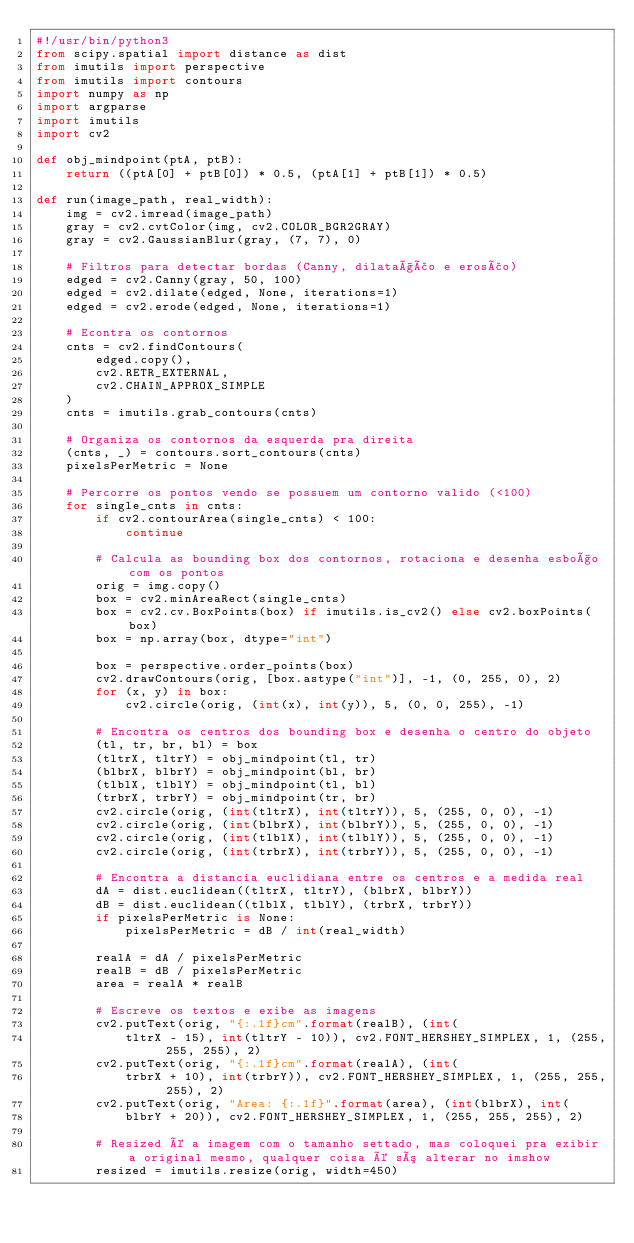<code> <loc_0><loc_0><loc_500><loc_500><_Python_>#!/usr/bin/python3
from scipy.spatial import distance as dist
from imutils import perspective
from imutils import contours
import numpy as np
import argparse
import imutils
import cv2

def obj_mindpoint(ptA, ptB):
    return ((ptA[0] + ptB[0]) * 0.5, (ptA[1] + ptB[1]) * 0.5)

def run(image_path, real_width):
    img = cv2.imread(image_path)
    gray = cv2.cvtColor(img, cv2.COLOR_BGR2GRAY)
    gray = cv2.GaussianBlur(gray, (7, 7), 0)

    # Filtros para detectar bordas (Canny, dilatação e erosão)
    edged = cv2.Canny(gray, 50, 100)
    edged = cv2.dilate(edged, None, iterations=1)
    edged = cv2.erode(edged, None, iterations=1)

    # Econtra os contornos
    cnts = cv2.findContours(
        edged.copy(), 
        cv2.RETR_EXTERNAL,
        cv2.CHAIN_APPROX_SIMPLE
    )
    cnts = imutils.grab_contours(cnts)

    # Organiza os contornos da esquerda pra direita
    (cnts, _) = contours.sort_contours(cnts)
    pixelsPerMetric = None

    # Percorre os pontos vendo se possuem um contorno valido (<100)
    for single_cnts in cnts:
        if cv2.contourArea(single_cnts) < 100:
            continue

        # Calcula as bounding box dos contornos, rotaciona e desenha esboço com os pontos
        orig = img.copy()
        box = cv2.minAreaRect(single_cnts)
        box = cv2.cv.BoxPoints(box) if imutils.is_cv2() else cv2.boxPoints(box)
        box = np.array(box, dtype="int")

        box = perspective.order_points(box)
        cv2.drawContours(orig, [box.astype("int")], -1, (0, 255, 0), 2)
        for (x, y) in box:
            cv2.circle(orig, (int(x), int(y)), 5, (0, 0, 255), -1)

        # Encontra os centros dos bounding box e desenha o centro do objeto
        (tl, tr, br, bl) = box
        (tltrX, tltrY) = obj_mindpoint(tl, tr)
        (blbrX, blbrY) = obj_mindpoint(bl, br)
        (tlblX, tlblY) = obj_mindpoint(tl, bl)
        (trbrX, trbrY) = obj_mindpoint(tr, br)
        cv2.circle(orig, (int(tltrX), int(tltrY)), 5, (255, 0, 0), -1)
        cv2.circle(orig, (int(blbrX), int(blbrY)), 5, (255, 0, 0), -1)
        cv2.circle(orig, (int(tlblX), int(tlblY)), 5, (255, 0, 0), -1)
        cv2.circle(orig, (int(trbrX), int(trbrY)), 5, (255, 0, 0), -1)

        # Encontra a distancia euclidiana entre os centros e a medida real
        dA = dist.euclidean((tltrX, tltrY), (blbrX, blbrY))
        dB = dist.euclidean((tlblX, tlblY), (trbrX, trbrY))
        if pixelsPerMetric is None:
            pixelsPerMetric = dB / int(real_width)

        realA = dA / pixelsPerMetric
        realB = dB / pixelsPerMetric
        area = realA * realB

        # Escreve os textos e exibe as imagens
        cv2.putText(orig, "{:.1f}cm".format(realB), (int(
            tltrX - 15), int(tltrY - 10)), cv2.FONT_HERSHEY_SIMPLEX, 1, (255, 255, 255), 2)
        cv2.putText(orig, "{:.1f}cm".format(realA), (int(
            trbrX + 10), int(trbrY)), cv2.FONT_HERSHEY_SIMPLEX, 1, (255, 255, 255), 2)
        cv2.putText(orig, "Area: {:.1f}".format(area), (int(blbrX), int(
            blbrY + 20)), cv2.FONT_HERSHEY_SIMPLEX, 1, (255, 255, 255), 2)

        # Resized é a imagem com o tamanho settado, mas coloquei pra exibir a original mesmo, qualquer coisa é só alterar no imshow
        resized = imutils.resize(orig, width=450)</code> 